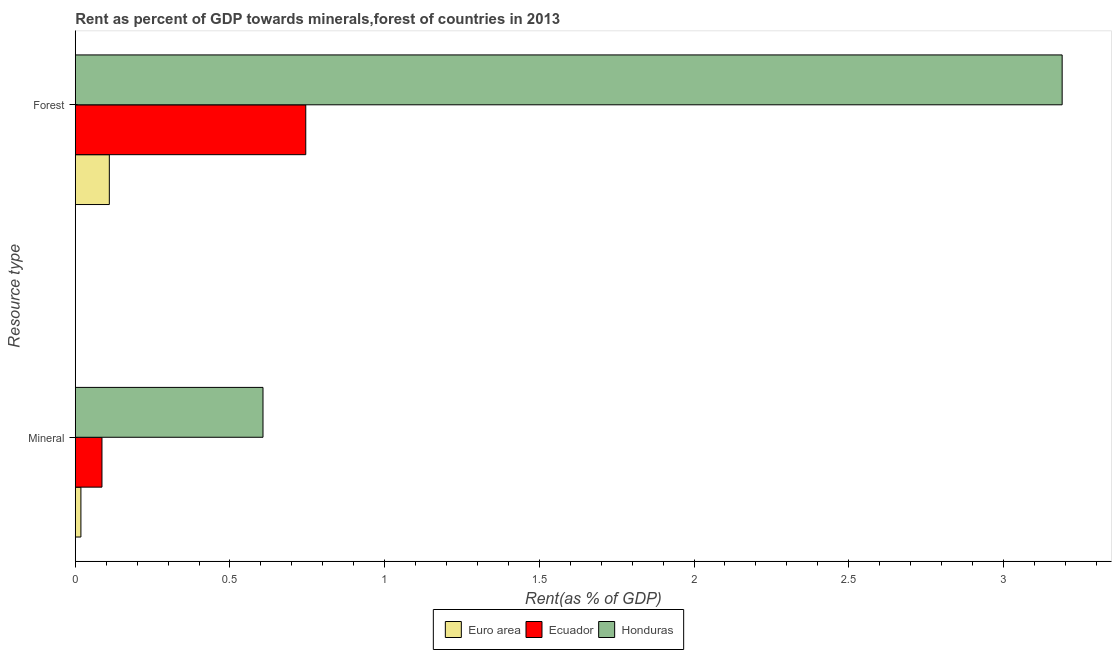How many different coloured bars are there?
Keep it short and to the point. 3. Are the number of bars per tick equal to the number of legend labels?
Ensure brevity in your answer.  Yes. Are the number of bars on each tick of the Y-axis equal?
Make the answer very short. Yes. How many bars are there on the 1st tick from the bottom?
Ensure brevity in your answer.  3. What is the label of the 1st group of bars from the top?
Provide a succinct answer. Forest. What is the forest rent in Honduras?
Ensure brevity in your answer.  3.19. Across all countries, what is the maximum forest rent?
Offer a very short reply. 3.19. Across all countries, what is the minimum mineral rent?
Make the answer very short. 0.02. In which country was the forest rent maximum?
Offer a very short reply. Honduras. What is the total forest rent in the graph?
Your answer should be very brief. 4.04. What is the difference between the mineral rent in Honduras and that in Ecuador?
Offer a terse response. 0.52. What is the difference between the mineral rent in Euro area and the forest rent in Honduras?
Your answer should be compact. -3.17. What is the average forest rent per country?
Your response must be concise. 1.35. What is the difference between the forest rent and mineral rent in Ecuador?
Your response must be concise. 0.66. What is the ratio of the mineral rent in Ecuador to that in Honduras?
Your answer should be very brief. 0.14. What does the 1st bar from the top in Forest represents?
Provide a short and direct response. Honduras. What does the 3rd bar from the bottom in Mineral represents?
Make the answer very short. Honduras. How many countries are there in the graph?
Provide a short and direct response. 3. Does the graph contain grids?
Offer a very short reply. No. Where does the legend appear in the graph?
Keep it short and to the point. Bottom center. What is the title of the graph?
Make the answer very short. Rent as percent of GDP towards minerals,forest of countries in 2013. Does "South Sudan" appear as one of the legend labels in the graph?
Offer a very short reply. No. What is the label or title of the X-axis?
Keep it short and to the point. Rent(as % of GDP). What is the label or title of the Y-axis?
Provide a short and direct response. Resource type. What is the Rent(as % of GDP) of Euro area in Mineral?
Your response must be concise. 0.02. What is the Rent(as % of GDP) in Ecuador in Mineral?
Your response must be concise. 0.09. What is the Rent(as % of GDP) of Honduras in Mineral?
Offer a terse response. 0.61. What is the Rent(as % of GDP) of Euro area in Forest?
Make the answer very short. 0.11. What is the Rent(as % of GDP) of Ecuador in Forest?
Your response must be concise. 0.74. What is the Rent(as % of GDP) of Honduras in Forest?
Offer a terse response. 3.19. Across all Resource type, what is the maximum Rent(as % of GDP) of Euro area?
Make the answer very short. 0.11. Across all Resource type, what is the maximum Rent(as % of GDP) in Ecuador?
Your answer should be compact. 0.74. Across all Resource type, what is the maximum Rent(as % of GDP) of Honduras?
Offer a terse response. 3.19. Across all Resource type, what is the minimum Rent(as % of GDP) in Euro area?
Your answer should be very brief. 0.02. Across all Resource type, what is the minimum Rent(as % of GDP) in Ecuador?
Your answer should be very brief. 0.09. Across all Resource type, what is the minimum Rent(as % of GDP) of Honduras?
Your response must be concise. 0.61. What is the total Rent(as % of GDP) in Euro area in the graph?
Make the answer very short. 0.13. What is the total Rent(as % of GDP) of Ecuador in the graph?
Provide a succinct answer. 0.83. What is the total Rent(as % of GDP) in Honduras in the graph?
Keep it short and to the point. 3.8. What is the difference between the Rent(as % of GDP) of Euro area in Mineral and that in Forest?
Your response must be concise. -0.09. What is the difference between the Rent(as % of GDP) of Ecuador in Mineral and that in Forest?
Offer a terse response. -0.66. What is the difference between the Rent(as % of GDP) of Honduras in Mineral and that in Forest?
Offer a very short reply. -2.58. What is the difference between the Rent(as % of GDP) of Euro area in Mineral and the Rent(as % of GDP) of Ecuador in Forest?
Offer a very short reply. -0.73. What is the difference between the Rent(as % of GDP) of Euro area in Mineral and the Rent(as % of GDP) of Honduras in Forest?
Provide a short and direct response. -3.17. What is the difference between the Rent(as % of GDP) of Ecuador in Mineral and the Rent(as % of GDP) of Honduras in Forest?
Your response must be concise. -3.1. What is the average Rent(as % of GDP) of Euro area per Resource type?
Give a very brief answer. 0.06. What is the average Rent(as % of GDP) in Ecuador per Resource type?
Make the answer very short. 0.42. What is the average Rent(as % of GDP) of Honduras per Resource type?
Offer a terse response. 1.9. What is the difference between the Rent(as % of GDP) in Euro area and Rent(as % of GDP) in Ecuador in Mineral?
Provide a short and direct response. -0.07. What is the difference between the Rent(as % of GDP) in Euro area and Rent(as % of GDP) in Honduras in Mineral?
Offer a terse response. -0.59. What is the difference between the Rent(as % of GDP) in Ecuador and Rent(as % of GDP) in Honduras in Mineral?
Offer a terse response. -0.52. What is the difference between the Rent(as % of GDP) in Euro area and Rent(as % of GDP) in Ecuador in Forest?
Your answer should be compact. -0.64. What is the difference between the Rent(as % of GDP) of Euro area and Rent(as % of GDP) of Honduras in Forest?
Give a very brief answer. -3.08. What is the difference between the Rent(as % of GDP) of Ecuador and Rent(as % of GDP) of Honduras in Forest?
Offer a very short reply. -2.44. What is the ratio of the Rent(as % of GDP) in Euro area in Mineral to that in Forest?
Offer a very short reply. 0.16. What is the ratio of the Rent(as % of GDP) of Ecuador in Mineral to that in Forest?
Your answer should be compact. 0.12. What is the ratio of the Rent(as % of GDP) of Honduras in Mineral to that in Forest?
Your answer should be compact. 0.19. What is the difference between the highest and the second highest Rent(as % of GDP) of Euro area?
Offer a terse response. 0.09. What is the difference between the highest and the second highest Rent(as % of GDP) in Ecuador?
Make the answer very short. 0.66. What is the difference between the highest and the second highest Rent(as % of GDP) in Honduras?
Ensure brevity in your answer.  2.58. What is the difference between the highest and the lowest Rent(as % of GDP) of Euro area?
Provide a succinct answer. 0.09. What is the difference between the highest and the lowest Rent(as % of GDP) in Ecuador?
Keep it short and to the point. 0.66. What is the difference between the highest and the lowest Rent(as % of GDP) in Honduras?
Your response must be concise. 2.58. 